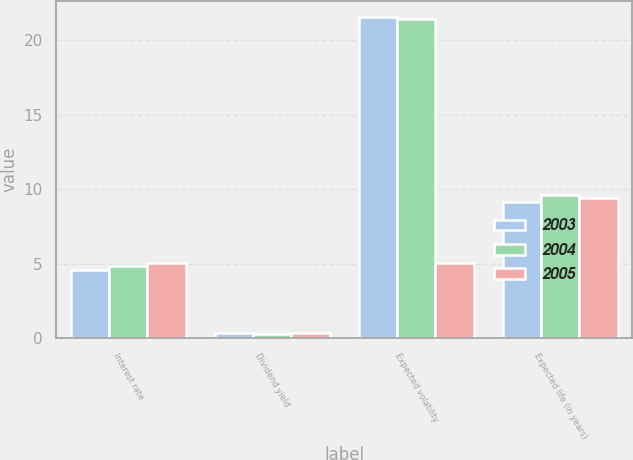<chart> <loc_0><loc_0><loc_500><loc_500><stacked_bar_chart><ecel><fcel>Interest rate<fcel>Dividend yield<fcel>Expected volatility<fcel>Expected life (in years)<nl><fcel>2003<fcel>4.55<fcel>0.37<fcel>21.53<fcel>9.15<nl><fcel>2004<fcel>4.82<fcel>0.32<fcel>21.41<fcel>9.58<nl><fcel>2005<fcel>5.07<fcel>0.38<fcel>5.07<fcel>9.42<nl></chart> 